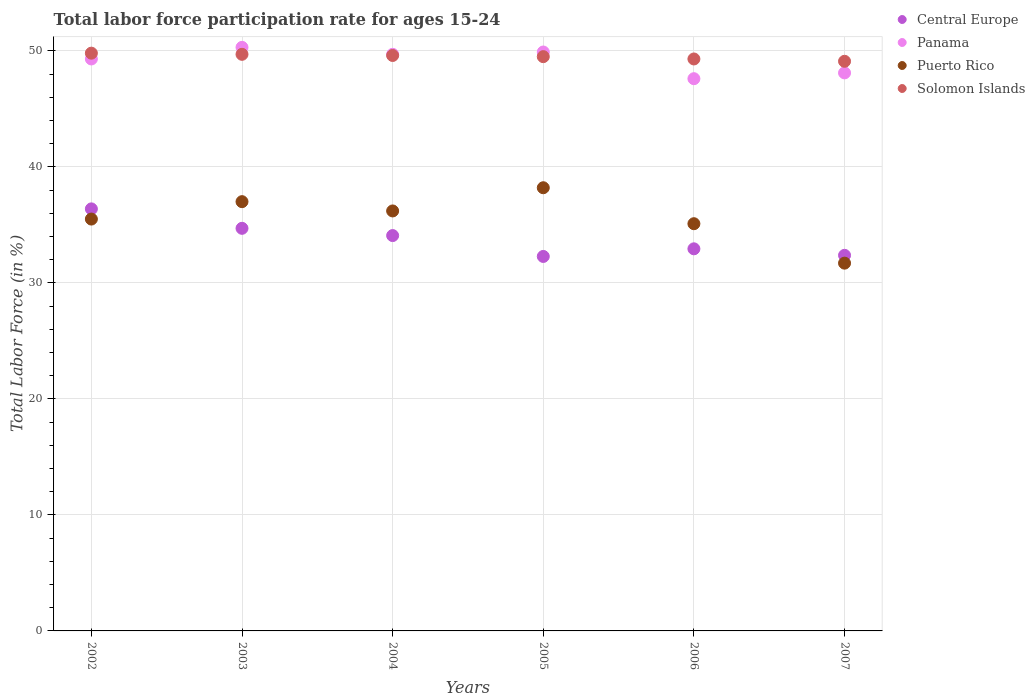How many different coloured dotlines are there?
Your response must be concise. 4. What is the labor force participation rate in Central Europe in 2004?
Give a very brief answer. 34.08. Across all years, what is the maximum labor force participation rate in Panama?
Provide a succinct answer. 50.3. Across all years, what is the minimum labor force participation rate in Solomon Islands?
Your response must be concise. 49.1. In which year was the labor force participation rate in Puerto Rico maximum?
Your answer should be compact. 2005. In which year was the labor force participation rate in Central Europe minimum?
Offer a very short reply. 2005. What is the total labor force participation rate in Central Europe in the graph?
Your response must be concise. 202.75. What is the difference between the labor force participation rate in Panama in 2003 and that in 2005?
Provide a succinct answer. 0.4. What is the difference between the labor force participation rate in Panama in 2006 and the labor force participation rate in Central Europe in 2007?
Offer a very short reply. 15.22. What is the average labor force participation rate in Panama per year?
Offer a very short reply. 49.15. In the year 2004, what is the difference between the labor force participation rate in Panama and labor force participation rate in Solomon Islands?
Offer a terse response. 0.1. In how many years, is the labor force participation rate in Solomon Islands greater than 30 %?
Ensure brevity in your answer.  6. What is the ratio of the labor force participation rate in Central Europe in 2003 to that in 2007?
Provide a short and direct response. 1.07. Is the labor force participation rate in Solomon Islands in 2004 less than that in 2006?
Ensure brevity in your answer.  No. Is the difference between the labor force participation rate in Panama in 2004 and 2007 greater than the difference between the labor force participation rate in Solomon Islands in 2004 and 2007?
Make the answer very short. Yes. What is the difference between the highest and the second highest labor force participation rate in Central Europe?
Provide a succinct answer. 1.68. What is the difference between the highest and the lowest labor force participation rate in Puerto Rico?
Make the answer very short. 6.5. In how many years, is the labor force participation rate in Puerto Rico greater than the average labor force participation rate in Puerto Rico taken over all years?
Your response must be concise. 3. Is it the case that in every year, the sum of the labor force participation rate in Panama and labor force participation rate in Solomon Islands  is greater than the labor force participation rate in Puerto Rico?
Ensure brevity in your answer.  Yes. Does the labor force participation rate in Solomon Islands monotonically increase over the years?
Provide a succinct answer. No. Is the labor force participation rate in Panama strictly greater than the labor force participation rate in Solomon Islands over the years?
Offer a very short reply. No. How many dotlines are there?
Offer a very short reply. 4. How many years are there in the graph?
Make the answer very short. 6. What is the difference between two consecutive major ticks on the Y-axis?
Offer a terse response. 10. Does the graph contain grids?
Your answer should be very brief. Yes. How many legend labels are there?
Provide a short and direct response. 4. How are the legend labels stacked?
Ensure brevity in your answer.  Vertical. What is the title of the graph?
Your answer should be very brief. Total labor force participation rate for ages 15-24. Does "San Marino" appear as one of the legend labels in the graph?
Ensure brevity in your answer.  No. What is the Total Labor Force (in %) of Central Europe in 2002?
Your response must be concise. 36.38. What is the Total Labor Force (in %) of Panama in 2002?
Provide a succinct answer. 49.3. What is the Total Labor Force (in %) in Puerto Rico in 2002?
Your answer should be very brief. 35.5. What is the Total Labor Force (in %) in Solomon Islands in 2002?
Offer a terse response. 49.8. What is the Total Labor Force (in %) in Central Europe in 2003?
Your response must be concise. 34.7. What is the Total Labor Force (in %) in Panama in 2003?
Offer a terse response. 50.3. What is the Total Labor Force (in %) in Solomon Islands in 2003?
Make the answer very short. 49.7. What is the Total Labor Force (in %) in Central Europe in 2004?
Offer a very short reply. 34.08. What is the Total Labor Force (in %) of Panama in 2004?
Offer a terse response. 49.7. What is the Total Labor Force (in %) in Puerto Rico in 2004?
Your answer should be very brief. 36.2. What is the Total Labor Force (in %) in Solomon Islands in 2004?
Offer a very short reply. 49.6. What is the Total Labor Force (in %) of Central Europe in 2005?
Offer a terse response. 32.28. What is the Total Labor Force (in %) in Panama in 2005?
Give a very brief answer. 49.9. What is the Total Labor Force (in %) in Puerto Rico in 2005?
Offer a terse response. 38.2. What is the Total Labor Force (in %) in Solomon Islands in 2005?
Offer a very short reply. 49.5. What is the Total Labor Force (in %) of Central Europe in 2006?
Keep it short and to the point. 32.94. What is the Total Labor Force (in %) in Panama in 2006?
Your answer should be compact. 47.6. What is the Total Labor Force (in %) in Puerto Rico in 2006?
Your response must be concise. 35.1. What is the Total Labor Force (in %) in Solomon Islands in 2006?
Provide a short and direct response. 49.3. What is the Total Labor Force (in %) in Central Europe in 2007?
Offer a terse response. 32.38. What is the Total Labor Force (in %) in Panama in 2007?
Keep it short and to the point. 48.1. What is the Total Labor Force (in %) of Puerto Rico in 2007?
Ensure brevity in your answer.  31.7. What is the Total Labor Force (in %) in Solomon Islands in 2007?
Give a very brief answer. 49.1. Across all years, what is the maximum Total Labor Force (in %) in Central Europe?
Make the answer very short. 36.38. Across all years, what is the maximum Total Labor Force (in %) of Panama?
Offer a terse response. 50.3. Across all years, what is the maximum Total Labor Force (in %) in Puerto Rico?
Offer a terse response. 38.2. Across all years, what is the maximum Total Labor Force (in %) in Solomon Islands?
Your response must be concise. 49.8. Across all years, what is the minimum Total Labor Force (in %) in Central Europe?
Provide a short and direct response. 32.28. Across all years, what is the minimum Total Labor Force (in %) of Panama?
Give a very brief answer. 47.6. Across all years, what is the minimum Total Labor Force (in %) of Puerto Rico?
Provide a succinct answer. 31.7. Across all years, what is the minimum Total Labor Force (in %) of Solomon Islands?
Provide a short and direct response. 49.1. What is the total Total Labor Force (in %) of Central Europe in the graph?
Make the answer very short. 202.75. What is the total Total Labor Force (in %) in Panama in the graph?
Your answer should be very brief. 294.9. What is the total Total Labor Force (in %) in Puerto Rico in the graph?
Offer a terse response. 213.7. What is the total Total Labor Force (in %) in Solomon Islands in the graph?
Keep it short and to the point. 297. What is the difference between the Total Labor Force (in %) of Central Europe in 2002 and that in 2003?
Offer a terse response. 1.68. What is the difference between the Total Labor Force (in %) in Central Europe in 2002 and that in 2004?
Your answer should be compact. 2.3. What is the difference between the Total Labor Force (in %) in Puerto Rico in 2002 and that in 2004?
Offer a terse response. -0.7. What is the difference between the Total Labor Force (in %) in Solomon Islands in 2002 and that in 2004?
Your response must be concise. 0.2. What is the difference between the Total Labor Force (in %) of Central Europe in 2002 and that in 2005?
Your answer should be very brief. 4.1. What is the difference between the Total Labor Force (in %) of Puerto Rico in 2002 and that in 2005?
Keep it short and to the point. -2.7. What is the difference between the Total Labor Force (in %) in Solomon Islands in 2002 and that in 2005?
Keep it short and to the point. 0.3. What is the difference between the Total Labor Force (in %) in Central Europe in 2002 and that in 2006?
Give a very brief answer. 3.44. What is the difference between the Total Labor Force (in %) of Central Europe in 2002 and that in 2007?
Keep it short and to the point. 4. What is the difference between the Total Labor Force (in %) in Solomon Islands in 2002 and that in 2007?
Offer a terse response. 0.7. What is the difference between the Total Labor Force (in %) of Central Europe in 2003 and that in 2004?
Offer a terse response. 0.63. What is the difference between the Total Labor Force (in %) of Panama in 2003 and that in 2004?
Offer a terse response. 0.6. What is the difference between the Total Labor Force (in %) of Puerto Rico in 2003 and that in 2004?
Your response must be concise. 0.8. What is the difference between the Total Labor Force (in %) in Solomon Islands in 2003 and that in 2004?
Give a very brief answer. 0.1. What is the difference between the Total Labor Force (in %) in Central Europe in 2003 and that in 2005?
Your answer should be compact. 2.42. What is the difference between the Total Labor Force (in %) in Puerto Rico in 2003 and that in 2005?
Your response must be concise. -1.2. What is the difference between the Total Labor Force (in %) of Central Europe in 2003 and that in 2006?
Make the answer very short. 1.77. What is the difference between the Total Labor Force (in %) in Solomon Islands in 2003 and that in 2006?
Make the answer very short. 0.4. What is the difference between the Total Labor Force (in %) of Central Europe in 2003 and that in 2007?
Ensure brevity in your answer.  2.33. What is the difference between the Total Labor Force (in %) of Puerto Rico in 2003 and that in 2007?
Keep it short and to the point. 5.3. What is the difference between the Total Labor Force (in %) in Solomon Islands in 2003 and that in 2007?
Offer a very short reply. 0.6. What is the difference between the Total Labor Force (in %) in Central Europe in 2004 and that in 2005?
Offer a very short reply. 1.8. What is the difference between the Total Labor Force (in %) in Panama in 2004 and that in 2005?
Ensure brevity in your answer.  -0.2. What is the difference between the Total Labor Force (in %) in Puerto Rico in 2004 and that in 2005?
Your response must be concise. -2. What is the difference between the Total Labor Force (in %) in Central Europe in 2004 and that in 2006?
Your answer should be compact. 1.14. What is the difference between the Total Labor Force (in %) of Panama in 2004 and that in 2006?
Offer a terse response. 2.1. What is the difference between the Total Labor Force (in %) of Puerto Rico in 2004 and that in 2006?
Your answer should be compact. 1.1. What is the difference between the Total Labor Force (in %) of Solomon Islands in 2004 and that in 2006?
Give a very brief answer. 0.3. What is the difference between the Total Labor Force (in %) of Central Europe in 2004 and that in 2007?
Provide a succinct answer. 1.7. What is the difference between the Total Labor Force (in %) of Puerto Rico in 2004 and that in 2007?
Offer a terse response. 4.5. What is the difference between the Total Labor Force (in %) of Central Europe in 2005 and that in 2006?
Your answer should be compact. -0.66. What is the difference between the Total Labor Force (in %) of Panama in 2005 and that in 2006?
Keep it short and to the point. 2.3. What is the difference between the Total Labor Force (in %) of Central Europe in 2005 and that in 2007?
Your response must be concise. -0.1. What is the difference between the Total Labor Force (in %) in Puerto Rico in 2005 and that in 2007?
Provide a succinct answer. 6.5. What is the difference between the Total Labor Force (in %) in Solomon Islands in 2005 and that in 2007?
Your answer should be very brief. 0.4. What is the difference between the Total Labor Force (in %) of Central Europe in 2006 and that in 2007?
Keep it short and to the point. 0.56. What is the difference between the Total Labor Force (in %) of Panama in 2006 and that in 2007?
Make the answer very short. -0.5. What is the difference between the Total Labor Force (in %) in Puerto Rico in 2006 and that in 2007?
Provide a succinct answer. 3.4. What is the difference between the Total Labor Force (in %) in Central Europe in 2002 and the Total Labor Force (in %) in Panama in 2003?
Offer a very short reply. -13.92. What is the difference between the Total Labor Force (in %) of Central Europe in 2002 and the Total Labor Force (in %) of Puerto Rico in 2003?
Give a very brief answer. -0.62. What is the difference between the Total Labor Force (in %) in Central Europe in 2002 and the Total Labor Force (in %) in Solomon Islands in 2003?
Offer a very short reply. -13.32. What is the difference between the Total Labor Force (in %) in Panama in 2002 and the Total Labor Force (in %) in Solomon Islands in 2003?
Ensure brevity in your answer.  -0.4. What is the difference between the Total Labor Force (in %) in Puerto Rico in 2002 and the Total Labor Force (in %) in Solomon Islands in 2003?
Give a very brief answer. -14.2. What is the difference between the Total Labor Force (in %) in Central Europe in 2002 and the Total Labor Force (in %) in Panama in 2004?
Offer a very short reply. -13.32. What is the difference between the Total Labor Force (in %) in Central Europe in 2002 and the Total Labor Force (in %) in Puerto Rico in 2004?
Give a very brief answer. 0.18. What is the difference between the Total Labor Force (in %) in Central Europe in 2002 and the Total Labor Force (in %) in Solomon Islands in 2004?
Provide a succinct answer. -13.22. What is the difference between the Total Labor Force (in %) in Panama in 2002 and the Total Labor Force (in %) in Puerto Rico in 2004?
Your response must be concise. 13.1. What is the difference between the Total Labor Force (in %) of Puerto Rico in 2002 and the Total Labor Force (in %) of Solomon Islands in 2004?
Your response must be concise. -14.1. What is the difference between the Total Labor Force (in %) of Central Europe in 2002 and the Total Labor Force (in %) of Panama in 2005?
Make the answer very short. -13.52. What is the difference between the Total Labor Force (in %) in Central Europe in 2002 and the Total Labor Force (in %) in Puerto Rico in 2005?
Provide a succinct answer. -1.82. What is the difference between the Total Labor Force (in %) of Central Europe in 2002 and the Total Labor Force (in %) of Solomon Islands in 2005?
Make the answer very short. -13.12. What is the difference between the Total Labor Force (in %) in Panama in 2002 and the Total Labor Force (in %) in Solomon Islands in 2005?
Your answer should be compact. -0.2. What is the difference between the Total Labor Force (in %) in Central Europe in 2002 and the Total Labor Force (in %) in Panama in 2006?
Provide a short and direct response. -11.22. What is the difference between the Total Labor Force (in %) in Central Europe in 2002 and the Total Labor Force (in %) in Puerto Rico in 2006?
Offer a very short reply. 1.28. What is the difference between the Total Labor Force (in %) of Central Europe in 2002 and the Total Labor Force (in %) of Solomon Islands in 2006?
Ensure brevity in your answer.  -12.92. What is the difference between the Total Labor Force (in %) in Panama in 2002 and the Total Labor Force (in %) in Puerto Rico in 2006?
Offer a very short reply. 14.2. What is the difference between the Total Labor Force (in %) of Panama in 2002 and the Total Labor Force (in %) of Solomon Islands in 2006?
Give a very brief answer. 0. What is the difference between the Total Labor Force (in %) in Puerto Rico in 2002 and the Total Labor Force (in %) in Solomon Islands in 2006?
Provide a succinct answer. -13.8. What is the difference between the Total Labor Force (in %) of Central Europe in 2002 and the Total Labor Force (in %) of Panama in 2007?
Provide a succinct answer. -11.72. What is the difference between the Total Labor Force (in %) in Central Europe in 2002 and the Total Labor Force (in %) in Puerto Rico in 2007?
Offer a very short reply. 4.68. What is the difference between the Total Labor Force (in %) in Central Europe in 2002 and the Total Labor Force (in %) in Solomon Islands in 2007?
Give a very brief answer. -12.72. What is the difference between the Total Labor Force (in %) of Panama in 2002 and the Total Labor Force (in %) of Puerto Rico in 2007?
Offer a terse response. 17.6. What is the difference between the Total Labor Force (in %) of Puerto Rico in 2002 and the Total Labor Force (in %) of Solomon Islands in 2007?
Provide a short and direct response. -13.6. What is the difference between the Total Labor Force (in %) of Central Europe in 2003 and the Total Labor Force (in %) of Panama in 2004?
Offer a terse response. -15. What is the difference between the Total Labor Force (in %) in Central Europe in 2003 and the Total Labor Force (in %) in Puerto Rico in 2004?
Make the answer very short. -1.5. What is the difference between the Total Labor Force (in %) in Central Europe in 2003 and the Total Labor Force (in %) in Solomon Islands in 2004?
Your response must be concise. -14.9. What is the difference between the Total Labor Force (in %) of Central Europe in 2003 and the Total Labor Force (in %) of Panama in 2005?
Your response must be concise. -15.2. What is the difference between the Total Labor Force (in %) of Central Europe in 2003 and the Total Labor Force (in %) of Puerto Rico in 2005?
Ensure brevity in your answer.  -3.5. What is the difference between the Total Labor Force (in %) in Central Europe in 2003 and the Total Labor Force (in %) in Solomon Islands in 2005?
Make the answer very short. -14.8. What is the difference between the Total Labor Force (in %) of Panama in 2003 and the Total Labor Force (in %) of Puerto Rico in 2005?
Provide a succinct answer. 12.1. What is the difference between the Total Labor Force (in %) in Panama in 2003 and the Total Labor Force (in %) in Solomon Islands in 2005?
Your response must be concise. 0.8. What is the difference between the Total Labor Force (in %) of Puerto Rico in 2003 and the Total Labor Force (in %) of Solomon Islands in 2005?
Give a very brief answer. -12.5. What is the difference between the Total Labor Force (in %) in Central Europe in 2003 and the Total Labor Force (in %) in Panama in 2006?
Provide a short and direct response. -12.9. What is the difference between the Total Labor Force (in %) in Central Europe in 2003 and the Total Labor Force (in %) in Puerto Rico in 2006?
Offer a very short reply. -0.4. What is the difference between the Total Labor Force (in %) of Central Europe in 2003 and the Total Labor Force (in %) of Solomon Islands in 2006?
Your answer should be compact. -14.6. What is the difference between the Total Labor Force (in %) in Panama in 2003 and the Total Labor Force (in %) in Puerto Rico in 2006?
Offer a very short reply. 15.2. What is the difference between the Total Labor Force (in %) in Central Europe in 2003 and the Total Labor Force (in %) in Panama in 2007?
Keep it short and to the point. -13.4. What is the difference between the Total Labor Force (in %) in Central Europe in 2003 and the Total Labor Force (in %) in Puerto Rico in 2007?
Keep it short and to the point. 3. What is the difference between the Total Labor Force (in %) in Central Europe in 2003 and the Total Labor Force (in %) in Solomon Islands in 2007?
Make the answer very short. -14.4. What is the difference between the Total Labor Force (in %) in Panama in 2003 and the Total Labor Force (in %) in Puerto Rico in 2007?
Your answer should be very brief. 18.6. What is the difference between the Total Labor Force (in %) in Puerto Rico in 2003 and the Total Labor Force (in %) in Solomon Islands in 2007?
Ensure brevity in your answer.  -12.1. What is the difference between the Total Labor Force (in %) of Central Europe in 2004 and the Total Labor Force (in %) of Panama in 2005?
Keep it short and to the point. -15.82. What is the difference between the Total Labor Force (in %) in Central Europe in 2004 and the Total Labor Force (in %) in Puerto Rico in 2005?
Ensure brevity in your answer.  -4.12. What is the difference between the Total Labor Force (in %) of Central Europe in 2004 and the Total Labor Force (in %) of Solomon Islands in 2005?
Your response must be concise. -15.42. What is the difference between the Total Labor Force (in %) of Panama in 2004 and the Total Labor Force (in %) of Solomon Islands in 2005?
Give a very brief answer. 0.2. What is the difference between the Total Labor Force (in %) in Central Europe in 2004 and the Total Labor Force (in %) in Panama in 2006?
Your answer should be compact. -13.52. What is the difference between the Total Labor Force (in %) of Central Europe in 2004 and the Total Labor Force (in %) of Puerto Rico in 2006?
Keep it short and to the point. -1.02. What is the difference between the Total Labor Force (in %) in Central Europe in 2004 and the Total Labor Force (in %) in Solomon Islands in 2006?
Your response must be concise. -15.22. What is the difference between the Total Labor Force (in %) of Puerto Rico in 2004 and the Total Labor Force (in %) of Solomon Islands in 2006?
Your answer should be very brief. -13.1. What is the difference between the Total Labor Force (in %) of Central Europe in 2004 and the Total Labor Force (in %) of Panama in 2007?
Offer a terse response. -14.02. What is the difference between the Total Labor Force (in %) of Central Europe in 2004 and the Total Labor Force (in %) of Puerto Rico in 2007?
Give a very brief answer. 2.38. What is the difference between the Total Labor Force (in %) of Central Europe in 2004 and the Total Labor Force (in %) of Solomon Islands in 2007?
Your response must be concise. -15.02. What is the difference between the Total Labor Force (in %) of Panama in 2004 and the Total Labor Force (in %) of Puerto Rico in 2007?
Give a very brief answer. 18. What is the difference between the Total Labor Force (in %) of Panama in 2004 and the Total Labor Force (in %) of Solomon Islands in 2007?
Ensure brevity in your answer.  0.6. What is the difference between the Total Labor Force (in %) of Central Europe in 2005 and the Total Labor Force (in %) of Panama in 2006?
Provide a succinct answer. -15.32. What is the difference between the Total Labor Force (in %) of Central Europe in 2005 and the Total Labor Force (in %) of Puerto Rico in 2006?
Make the answer very short. -2.82. What is the difference between the Total Labor Force (in %) of Central Europe in 2005 and the Total Labor Force (in %) of Solomon Islands in 2006?
Your answer should be very brief. -17.02. What is the difference between the Total Labor Force (in %) of Puerto Rico in 2005 and the Total Labor Force (in %) of Solomon Islands in 2006?
Provide a succinct answer. -11.1. What is the difference between the Total Labor Force (in %) of Central Europe in 2005 and the Total Labor Force (in %) of Panama in 2007?
Offer a very short reply. -15.82. What is the difference between the Total Labor Force (in %) in Central Europe in 2005 and the Total Labor Force (in %) in Puerto Rico in 2007?
Provide a succinct answer. 0.58. What is the difference between the Total Labor Force (in %) of Central Europe in 2005 and the Total Labor Force (in %) of Solomon Islands in 2007?
Give a very brief answer. -16.82. What is the difference between the Total Labor Force (in %) of Panama in 2005 and the Total Labor Force (in %) of Puerto Rico in 2007?
Offer a terse response. 18.2. What is the difference between the Total Labor Force (in %) of Panama in 2005 and the Total Labor Force (in %) of Solomon Islands in 2007?
Provide a short and direct response. 0.8. What is the difference between the Total Labor Force (in %) of Puerto Rico in 2005 and the Total Labor Force (in %) of Solomon Islands in 2007?
Your answer should be very brief. -10.9. What is the difference between the Total Labor Force (in %) of Central Europe in 2006 and the Total Labor Force (in %) of Panama in 2007?
Ensure brevity in your answer.  -15.16. What is the difference between the Total Labor Force (in %) of Central Europe in 2006 and the Total Labor Force (in %) of Puerto Rico in 2007?
Provide a succinct answer. 1.24. What is the difference between the Total Labor Force (in %) in Central Europe in 2006 and the Total Labor Force (in %) in Solomon Islands in 2007?
Your response must be concise. -16.16. What is the difference between the Total Labor Force (in %) of Panama in 2006 and the Total Labor Force (in %) of Puerto Rico in 2007?
Offer a very short reply. 15.9. What is the average Total Labor Force (in %) in Central Europe per year?
Ensure brevity in your answer.  33.79. What is the average Total Labor Force (in %) of Panama per year?
Offer a very short reply. 49.15. What is the average Total Labor Force (in %) of Puerto Rico per year?
Your response must be concise. 35.62. What is the average Total Labor Force (in %) in Solomon Islands per year?
Ensure brevity in your answer.  49.5. In the year 2002, what is the difference between the Total Labor Force (in %) of Central Europe and Total Labor Force (in %) of Panama?
Your answer should be very brief. -12.92. In the year 2002, what is the difference between the Total Labor Force (in %) in Central Europe and Total Labor Force (in %) in Puerto Rico?
Your answer should be compact. 0.88. In the year 2002, what is the difference between the Total Labor Force (in %) in Central Europe and Total Labor Force (in %) in Solomon Islands?
Provide a succinct answer. -13.42. In the year 2002, what is the difference between the Total Labor Force (in %) of Panama and Total Labor Force (in %) of Solomon Islands?
Offer a terse response. -0.5. In the year 2002, what is the difference between the Total Labor Force (in %) of Puerto Rico and Total Labor Force (in %) of Solomon Islands?
Provide a succinct answer. -14.3. In the year 2003, what is the difference between the Total Labor Force (in %) in Central Europe and Total Labor Force (in %) in Panama?
Your answer should be compact. -15.6. In the year 2003, what is the difference between the Total Labor Force (in %) of Central Europe and Total Labor Force (in %) of Puerto Rico?
Make the answer very short. -2.3. In the year 2003, what is the difference between the Total Labor Force (in %) in Central Europe and Total Labor Force (in %) in Solomon Islands?
Your response must be concise. -15. In the year 2003, what is the difference between the Total Labor Force (in %) of Panama and Total Labor Force (in %) of Solomon Islands?
Your response must be concise. 0.6. In the year 2004, what is the difference between the Total Labor Force (in %) of Central Europe and Total Labor Force (in %) of Panama?
Give a very brief answer. -15.62. In the year 2004, what is the difference between the Total Labor Force (in %) in Central Europe and Total Labor Force (in %) in Puerto Rico?
Provide a short and direct response. -2.12. In the year 2004, what is the difference between the Total Labor Force (in %) of Central Europe and Total Labor Force (in %) of Solomon Islands?
Offer a very short reply. -15.52. In the year 2004, what is the difference between the Total Labor Force (in %) in Panama and Total Labor Force (in %) in Puerto Rico?
Offer a very short reply. 13.5. In the year 2005, what is the difference between the Total Labor Force (in %) of Central Europe and Total Labor Force (in %) of Panama?
Your answer should be very brief. -17.62. In the year 2005, what is the difference between the Total Labor Force (in %) of Central Europe and Total Labor Force (in %) of Puerto Rico?
Offer a very short reply. -5.92. In the year 2005, what is the difference between the Total Labor Force (in %) in Central Europe and Total Labor Force (in %) in Solomon Islands?
Offer a very short reply. -17.22. In the year 2005, what is the difference between the Total Labor Force (in %) of Panama and Total Labor Force (in %) of Solomon Islands?
Ensure brevity in your answer.  0.4. In the year 2005, what is the difference between the Total Labor Force (in %) in Puerto Rico and Total Labor Force (in %) in Solomon Islands?
Make the answer very short. -11.3. In the year 2006, what is the difference between the Total Labor Force (in %) in Central Europe and Total Labor Force (in %) in Panama?
Keep it short and to the point. -14.66. In the year 2006, what is the difference between the Total Labor Force (in %) of Central Europe and Total Labor Force (in %) of Puerto Rico?
Provide a short and direct response. -2.16. In the year 2006, what is the difference between the Total Labor Force (in %) in Central Europe and Total Labor Force (in %) in Solomon Islands?
Your answer should be compact. -16.36. In the year 2006, what is the difference between the Total Labor Force (in %) of Panama and Total Labor Force (in %) of Solomon Islands?
Offer a terse response. -1.7. In the year 2006, what is the difference between the Total Labor Force (in %) in Puerto Rico and Total Labor Force (in %) in Solomon Islands?
Your answer should be compact. -14.2. In the year 2007, what is the difference between the Total Labor Force (in %) in Central Europe and Total Labor Force (in %) in Panama?
Provide a succinct answer. -15.72. In the year 2007, what is the difference between the Total Labor Force (in %) in Central Europe and Total Labor Force (in %) in Puerto Rico?
Make the answer very short. 0.68. In the year 2007, what is the difference between the Total Labor Force (in %) in Central Europe and Total Labor Force (in %) in Solomon Islands?
Your answer should be compact. -16.72. In the year 2007, what is the difference between the Total Labor Force (in %) in Puerto Rico and Total Labor Force (in %) in Solomon Islands?
Keep it short and to the point. -17.4. What is the ratio of the Total Labor Force (in %) of Central Europe in 2002 to that in 2003?
Make the answer very short. 1.05. What is the ratio of the Total Labor Force (in %) of Panama in 2002 to that in 2003?
Provide a succinct answer. 0.98. What is the ratio of the Total Labor Force (in %) of Puerto Rico in 2002 to that in 2003?
Keep it short and to the point. 0.96. What is the ratio of the Total Labor Force (in %) of Central Europe in 2002 to that in 2004?
Keep it short and to the point. 1.07. What is the ratio of the Total Labor Force (in %) of Panama in 2002 to that in 2004?
Your response must be concise. 0.99. What is the ratio of the Total Labor Force (in %) of Puerto Rico in 2002 to that in 2004?
Make the answer very short. 0.98. What is the ratio of the Total Labor Force (in %) in Solomon Islands in 2002 to that in 2004?
Offer a very short reply. 1. What is the ratio of the Total Labor Force (in %) of Central Europe in 2002 to that in 2005?
Keep it short and to the point. 1.13. What is the ratio of the Total Labor Force (in %) in Puerto Rico in 2002 to that in 2005?
Provide a short and direct response. 0.93. What is the ratio of the Total Labor Force (in %) of Solomon Islands in 2002 to that in 2005?
Your response must be concise. 1.01. What is the ratio of the Total Labor Force (in %) of Central Europe in 2002 to that in 2006?
Your answer should be very brief. 1.1. What is the ratio of the Total Labor Force (in %) in Panama in 2002 to that in 2006?
Keep it short and to the point. 1.04. What is the ratio of the Total Labor Force (in %) in Puerto Rico in 2002 to that in 2006?
Provide a succinct answer. 1.01. What is the ratio of the Total Labor Force (in %) in Solomon Islands in 2002 to that in 2006?
Offer a very short reply. 1.01. What is the ratio of the Total Labor Force (in %) of Central Europe in 2002 to that in 2007?
Offer a very short reply. 1.12. What is the ratio of the Total Labor Force (in %) in Panama in 2002 to that in 2007?
Offer a very short reply. 1.02. What is the ratio of the Total Labor Force (in %) in Puerto Rico in 2002 to that in 2007?
Offer a terse response. 1.12. What is the ratio of the Total Labor Force (in %) of Solomon Islands in 2002 to that in 2007?
Provide a short and direct response. 1.01. What is the ratio of the Total Labor Force (in %) of Central Europe in 2003 to that in 2004?
Provide a succinct answer. 1.02. What is the ratio of the Total Labor Force (in %) of Panama in 2003 to that in 2004?
Ensure brevity in your answer.  1.01. What is the ratio of the Total Labor Force (in %) of Puerto Rico in 2003 to that in 2004?
Your answer should be very brief. 1.02. What is the ratio of the Total Labor Force (in %) in Central Europe in 2003 to that in 2005?
Provide a short and direct response. 1.08. What is the ratio of the Total Labor Force (in %) in Panama in 2003 to that in 2005?
Make the answer very short. 1.01. What is the ratio of the Total Labor Force (in %) of Puerto Rico in 2003 to that in 2005?
Provide a short and direct response. 0.97. What is the ratio of the Total Labor Force (in %) in Solomon Islands in 2003 to that in 2005?
Give a very brief answer. 1. What is the ratio of the Total Labor Force (in %) of Central Europe in 2003 to that in 2006?
Your response must be concise. 1.05. What is the ratio of the Total Labor Force (in %) in Panama in 2003 to that in 2006?
Keep it short and to the point. 1.06. What is the ratio of the Total Labor Force (in %) in Puerto Rico in 2003 to that in 2006?
Give a very brief answer. 1.05. What is the ratio of the Total Labor Force (in %) in Solomon Islands in 2003 to that in 2006?
Your response must be concise. 1.01. What is the ratio of the Total Labor Force (in %) in Central Europe in 2003 to that in 2007?
Keep it short and to the point. 1.07. What is the ratio of the Total Labor Force (in %) of Panama in 2003 to that in 2007?
Your response must be concise. 1.05. What is the ratio of the Total Labor Force (in %) in Puerto Rico in 2003 to that in 2007?
Give a very brief answer. 1.17. What is the ratio of the Total Labor Force (in %) in Solomon Islands in 2003 to that in 2007?
Provide a succinct answer. 1.01. What is the ratio of the Total Labor Force (in %) of Central Europe in 2004 to that in 2005?
Provide a short and direct response. 1.06. What is the ratio of the Total Labor Force (in %) in Puerto Rico in 2004 to that in 2005?
Provide a short and direct response. 0.95. What is the ratio of the Total Labor Force (in %) of Solomon Islands in 2004 to that in 2005?
Provide a short and direct response. 1. What is the ratio of the Total Labor Force (in %) in Central Europe in 2004 to that in 2006?
Keep it short and to the point. 1.03. What is the ratio of the Total Labor Force (in %) of Panama in 2004 to that in 2006?
Provide a short and direct response. 1.04. What is the ratio of the Total Labor Force (in %) of Puerto Rico in 2004 to that in 2006?
Your response must be concise. 1.03. What is the ratio of the Total Labor Force (in %) of Solomon Islands in 2004 to that in 2006?
Provide a succinct answer. 1.01. What is the ratio of the Total Labor Force (in %) of Central Europe in 2004 to that in 2007?
Provide a short and direct response. 1.05. What is the ratio of the Total Labor Force (in %) in Puerto Rico in 2004 to that in 2007?
Give a very brief answer. 1.14. What is the ratio of the Total Labor Force (in %) in Solomon Islands in 2004 to that in 2007?
Offer a terse response. 1.01. What is the ratio of the Total Labor Force (in %) of Panama in 2005 to that in 2006?
Your response must be concise. 1.05. What is the ratio of the Total Labor Force (in %) of Puerto Rico in 2005 to that in 2006?
Offer a terse response. 1.09. What is the ratio of the Total Labor Force (in %) in Central Europe in 2005 to that in 2007?
Your answer should be very brief. 1. What is the ratio of the Total Labor Force (in %) of Panama in 2005 to that in 2007?
Your answer should be compact. 1.04. What is the ratio of the Total Labor Force (in %) of Puerto Rico in 2005 to that in 2007?
Offer a terse response. 1.21. What is the ratio of the Total Labor Force (in %) of Central Europe in 2006 to that in 2007?
Make the answer very short. 1.02. What is the ratio of the Total Labor Force (in %) in Puerto Rico in 2006 to that in 2007?
Offer a terse response. 1.11. What is the ratio of the Total Labor Force (in %) in Solomon Islands in 2006 to that in 2007?
Offer a terse response. 1. What is the difference between the highest and the second highest Total Labor Force (in %) of Central Europe?
Your response must be concise. 1.68. What is the difference between the highest and the second highest Total Labor Force (in %) of Puerto Rico?
Your answer should be compact. 1.2. What is the difference between the highest and the second highest Total Labor Force (in %) in Solomon Islands?
Offer a very short reply. 0.1. What is the difference between the highest and the lowest Total Labor Force (in %) in Central Europe?
Offer a terse response. 4.1. What is the difference between the highest and the lowest Total Labor Force (in %) of Panama?
Give a very brief answer. 2.7. 